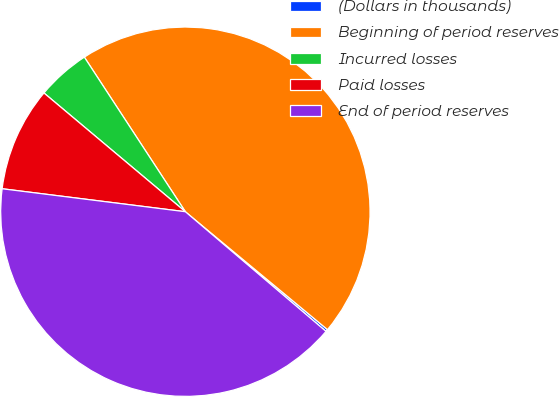Convert chart. <chart><loc_0><loc_0><loc_500><loc_500><pie_chart><fcel>(Dollars in thousands)<fcel>Beginning of period reserves<fcel>Incurred losses<fcel>Paid losses<fcel>End of period reserves<nl><fcel>0.2%<fcel>45.23%<fcel>4.67%<fcel>9.13%<fcel>40.76%<nl></chart> 